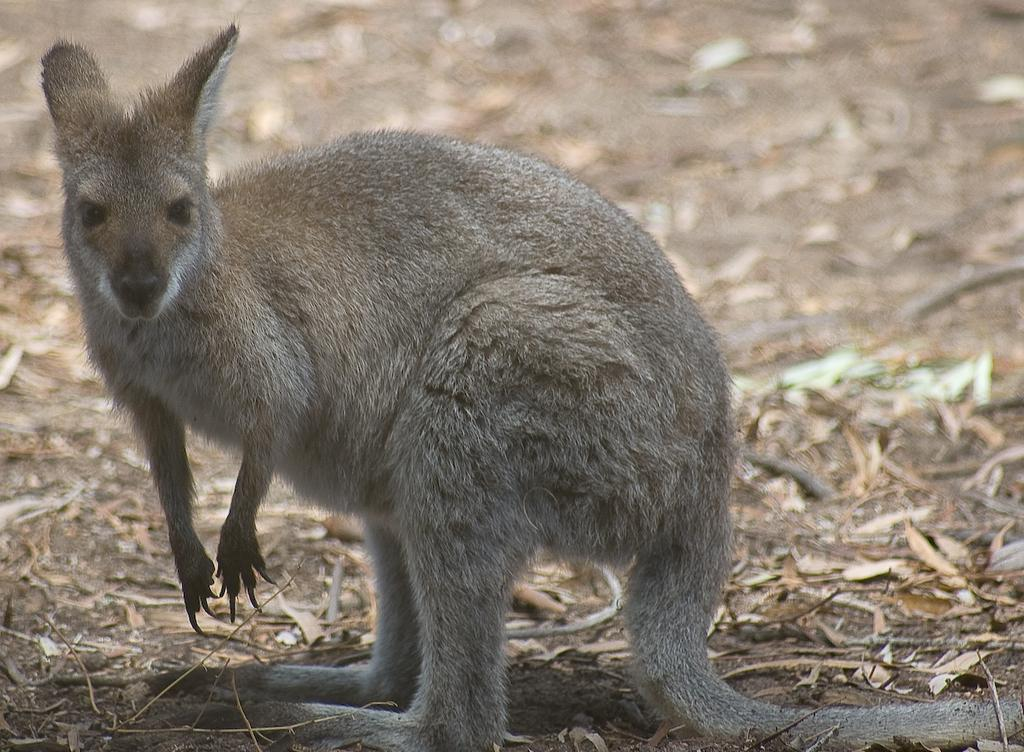What is the main subject in the foreground of the image? There is an animal in the foreground of the image. What is the position of the animal in the image? The animal is on the ground. What type of vegetation can be seen in the foreground of the image? There is dried grass in the foreground of the image. What type of environment might the image have been taken in? The image might have been taken in a forest. What rate of smoke is visible in the image? There is no smoke present in the image. What suggestion does the animal have for the viewer in the image? The image does not convey any suggestions from the animal; it is a static image. 